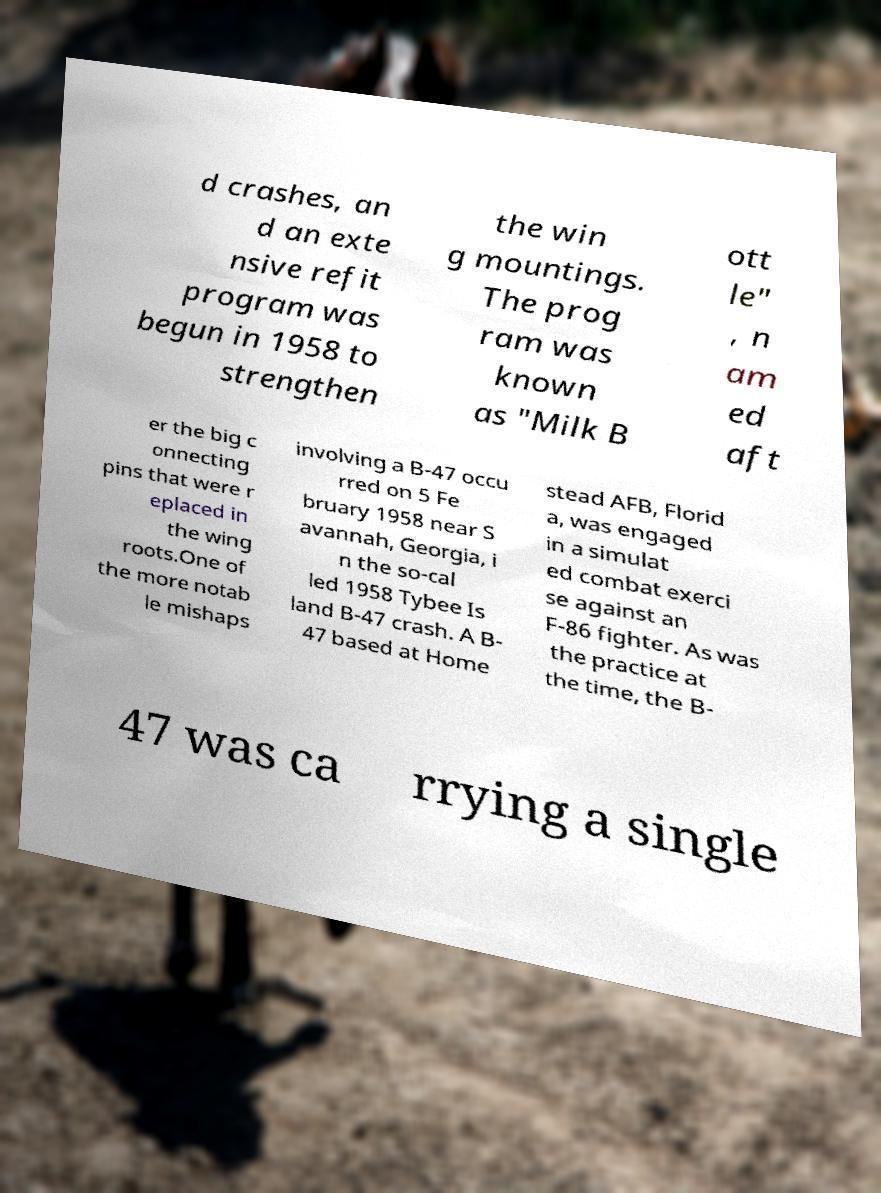Please identify and transcribe the text found in this image. d crashes, an d an exte nsive refit program was begun in 1958 to strengthen the win g mountings. The prog ram was known as "Milk B ott le" , n am ed aft er the big c onnecting pins that were r eplaced in the wing roots.One of the more notab le mishaps involving a B-47 occu rred on 5 Fe bruary 1958 near S avannah, Georgia, i n the so-cal led 1958 Tybee Is land B-47 crash. A B- 47 based at Home stead AFB, Florid a, was engaged in a simulat ed combat exerci se against an F-86 fighter. As was the practice at the time, the B- 47 was ca rrying a single 